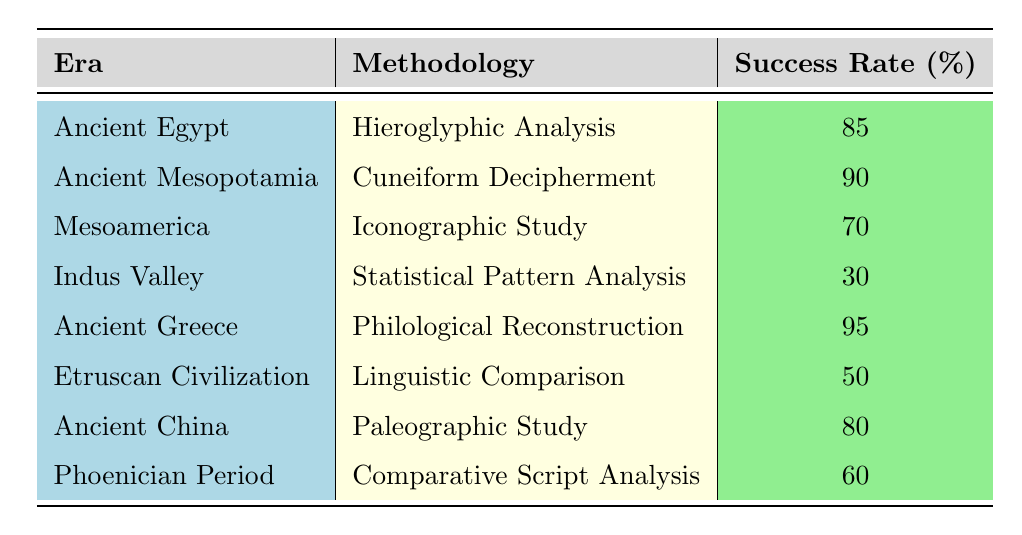What is the success rate for Ancient Greece using Philological Reconstruction? The table shows that the success rate for Ancient Greece with the methodology of Philological Reconstruction is directly listed as 95%.
Answer: 95 Which era had the highest success rate, and what was it? By scanning through the 'Success Rate' column, it can be observed that Ancient Greece holds the highest success rate at 95%.
Answer: Ancient Greece, 95% What is the average success rate across all the methodologies listed? To find the average, sum the success rates: (85 + 90 + 70 + 30 + 95 + 50 + 80 + 60) = 460. There are 8 methodologies listed, so the average is 460/8 = 57.5.
Answer: 57.5 Is the success rate for Iconographic Study greater than 75%? The table shows the success rate for Iconographic Study is 70%, which is less than 75%. Therefore, the answer is no.
Answer: No Calculate the difference in success rates between the highest and lowest rates. The highest success rate is 95% from Ancient Greece, and the lowest success rate is 30% from the Indus Valley. The difference is 95 - 30 = 65.
Answer: 65 Are there any methodologies with a success rate below 40%? By checking the 'Success Rate' column, it can be noted that the lowest value is 30% (Indus Valley), which indicates there is indeed a methodology below 40%.
Answer: Yes How many methodologies have a success rate of 80% or higher? The success rates of 80% or higher are: 85% (Ancient Egypt), 90% (Ancient Mesopotamia), 95% (Ancient Greece), and 80% (Ancient China). This gives a total of 4 methodologies.
Answer: 4 What is the success rate for Linguistic Comparison in Etruscan Civilization? The table indicates that the Etruscan Civilization has a success rate of 50% using the methodology of Linguistic Comparison.
Answer: 50 Which methodology had the lowest success rate, and what was the success rate? By examining the table, it's clear the methodology with the lowest success rate is Statistical Pattern Analysis, with a rate of 30% from the Indus Valley.
Answer: Statistical Pattern Analysis, 30 